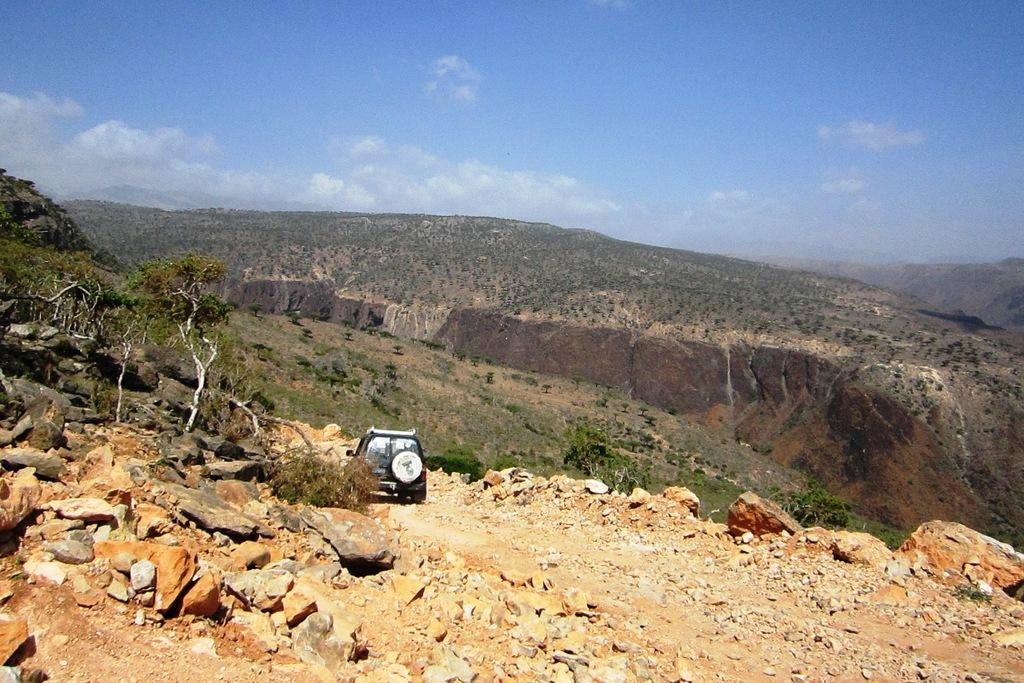What can be seen in the sky in the background of the image? There are clouds in the sky in the background of the image. What type of natural landscape is visible in the image? Hills, thicket, trees, and stones and rocks are visible in the image. What man-made object is present in the image? There is a vehicle in the image. How many sticks are being used to make a wish in the image? There are no sticks present in the image, and therefore no such activity can be observed. 